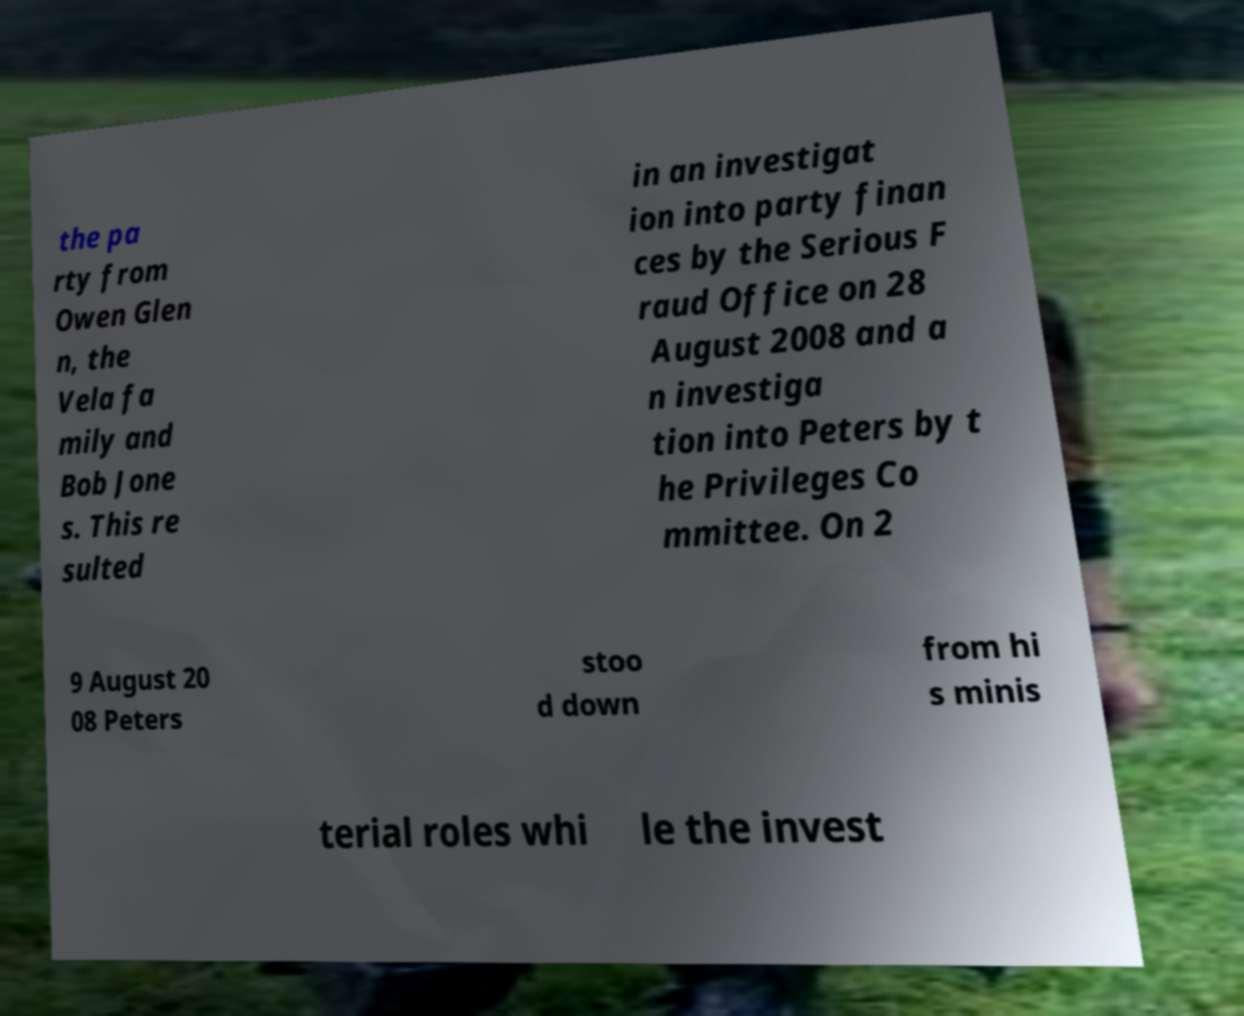Could you extract and type out the text from this image? the pa rty from Owen Glen n, the Vela fa mily and Bob Jone s. This re sulted in an investigat ion into party finan ces by the Serious F raud Office on 28 August 2008 and a n investiga tion into Peters by t he Privileges Co mmittee. On 2 9 August 20 08 Peters stoo d down from hi s minis terial roles whi le the invest 